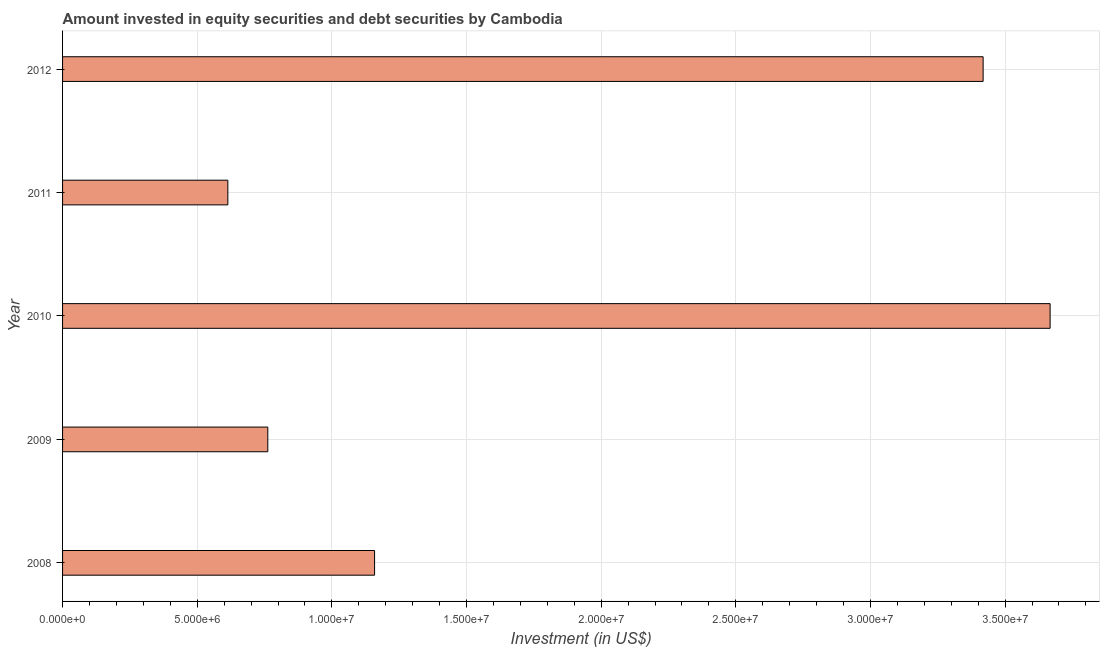Does the graph contain any zero values?
Keep it short and to the point. No. Does the graph contain grids?
Your answer should be compact. Yes. What is the title of the graph?
Ensure brevity in your answer.  Amount invested in equity securities and debt securities by Cambodia. What is the label or title of the X-axis?
Your answer should be compact. Investment (in US$). What is the label or title of the Y-axis?
Offer a very short reply. Year. What is the portfolio investment in 2010?
Ensure brevity in your answer.  3.67e+07. Across all years, what is the maximum portfolio investment?
Provide a succinct answer. 3.67e+07. Across all years, what is the minimum portfolio investment?
Your answer should be very brief. 6.14e+06. What is the sum of the portfolio investment?
Provide a succinct answer. 9.62e+07. What is the difference between the portfolio investment in 2008 and 2011?
Your answer should be very brief. 5.45e+06. What is the average portfolio investment per year?
Keep it short and to the point. 1.92e+07. What is the median portfolio investment?
Offer a terse response. 1.16e+07. In how many years, is the portfolio investment greater than 27000000 US$?
Keep it short and to the point. 2. Do a majority of the years between 2009 and 2010 (inclusive) have portfolio investment greater than 5000000 US$?
Make the answer very short. Yes. What is the ratio of the portfolio investment in 2011 to that in 2012?
Your answer should be compact. 0.18. Is the portfolio investment in 2008 less than that in 2012?
Provide a short and direct response. Yes. What is the difference between the highest and the second highest portfolio investment?
Keep it short and to the point. 2.49e+06. What is the difference between the highest and the lowest portfolio investment?
Your response must be concise. 3.05e+07. In how many years, is the portfolio investment greater than the average portfolio investment taken over all years?
Your answer should be compact. 2. Are all the bars in the graph horizontal?
Ensure brevity in your answer.  Yes. What is the Investment (in US$) in 2008?
Offer a terse response. 1.16e+07. What is the Investment (in US$) of 2009?
Ensure brevity in your answer.  7.62e+06. What is the Investment (in US$) of 2010?
Your answer should be very brief. 3.67e+07. What is the Investment (in US$) of 2011?
Your response must be concise. 6.14e+06. What is the Investment (in US$) in 2012?
Your answer should be compact. 3.42e+07. What is the difference between the Investment (in US$) in 2008 and 2009?
Keep it short and to the point. 3.97e+06. What is the difference between the Investment (in US$) in 2008 and 2010?
Your answer should be compact. -2.51e+07. What is the difference between the Investment (in US$) in 2008 and 2011?
Your answer should be compact. 5.45e+06. What is the difference between the Investment (in US$) in 2008 and 2012?
Provide a succinct answer. -2.26e+07. What is the difference between the Investment (in US$) in 2009 and 2010?
Make the answer very short. -2.90e+07. What is the difference between the Investment (in US$) in 2009 and 2011?
Offer a terse response. 1.48e+06. What is the difference between the Investment (in US$) in 2009 and 2012?
Ensure brevity in your answer.  -2.66e+07. What is the difference between the Investment (in US$) in 2010 and 2011?
Provide a short and direct response. 3.05e+07. What is the difference between the Investment (in US$) in 2010 and 2012?
Offer a very short reply. 2.49e+06. What is the difference between the Investment (in US$) in 2011 and 2012?
Provide a short and direct response. -2.80e+07. What is the ratio of the Investment (in US$) in 2008 to that in 2009?
Ensure brevity in your answer.  1.52. What is the ratio of the Investment (in US$) in 2008 to that in 2010?
Keep it short and to the point. 0.32. What is the ratio of the Investment (in US$) in 2008 to that in 2011?
Make the answer very short. 1.89. What is the ratio of the Investment (in US$) in 2008 to that in 2012?
Give a very brief answer. 0.34. What is the ratio of the Investment (in US$) in 2009 to that in 2010?
Provide a short and direct response. 0.21. What is the ratio of the Investment (in US$) in 2009 to that in 2011?
Give a very brief answer. 1.24. What is the ratio of the Investment (in US$) in 2009 to that in 2012?
Provide a short and direct response. 0.22. What is the ratio of the Investment (in US$) in 2010 to that in 2011?
Your response must be concise. 5.97. What is the ratio of the Investment (in US$) in 2010 to that in 2012?
Keep it short and to the point. 1.07. What is the ratio of the Investment (in US$) in 2011 to that in 2012?
Provide a short and direct response. 0.18. 